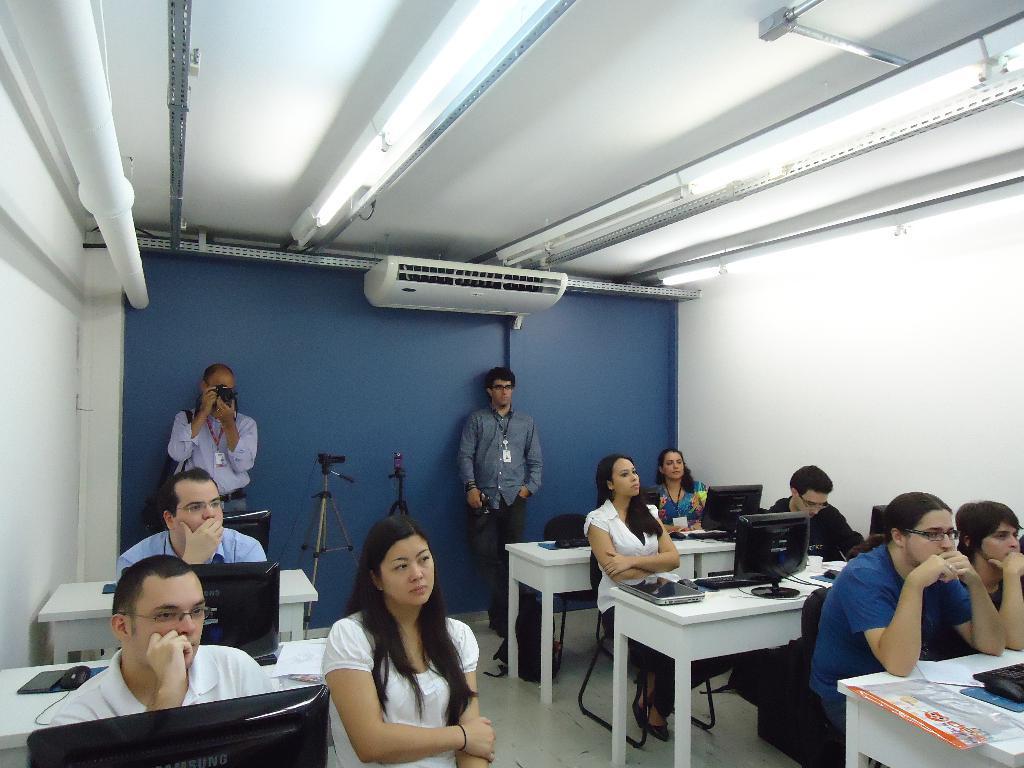Please provide a concise description of this image. In this picture we can see a group of people some are sitting on chairs and two are standing where one is taking picture with camera and in front of them there is table and on table we can see monitors, keyboard, mouse, papers and in background we can see wall, AC, lights, stands. 